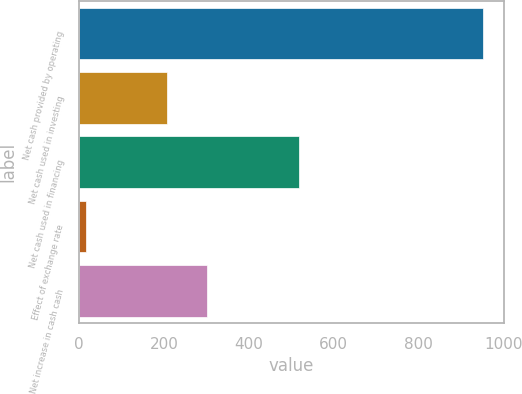Convert chart to OTSL. <chart><loc_0><loc_0><loc_500><loc_500><bar_chart><fcel>Net cash provided by operating<fcel>Net cash used in investing<fcel>Net cash used in financing<fcel>Effect of exchange rate<fcel>Net increase in cash cash<nl><fcel>952.6<fcel>208.1<fcel>518.4<fcel>16.4<fcel>301.72<nl></chart> 